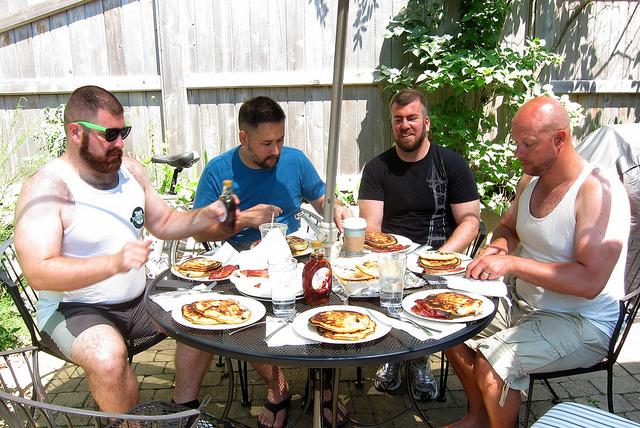How many men are in the picture?
Answer briefly. 4. Are they eating outside?
Concise answer only. Yes. How many men are bald?
Give a very brief answer. 1. 